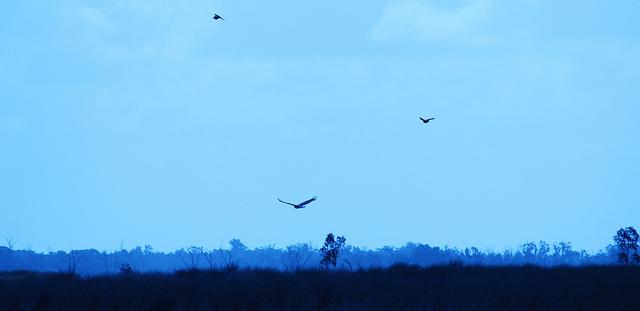Which bird seems closer?
Quick response, please. Bottom. What is flying?
Short answer required. Birds. How would the animals shown move if they were on the ground?
Answer briefly. Walk. Are they in the wild?
Give a very brief answer. Yes. What is getting ready to land?
Give a very brief answer. Bird. Are these birds flying in the same direction?
Concise answer only. Yes. How many birds are shown?
Concise answer only. 3. Is this someone's backyard?
Keep it brief. No. What kind of birds are these?
Write a very short answer. Hawks. What time of day is it?
Write a very short answer. Dusk. 